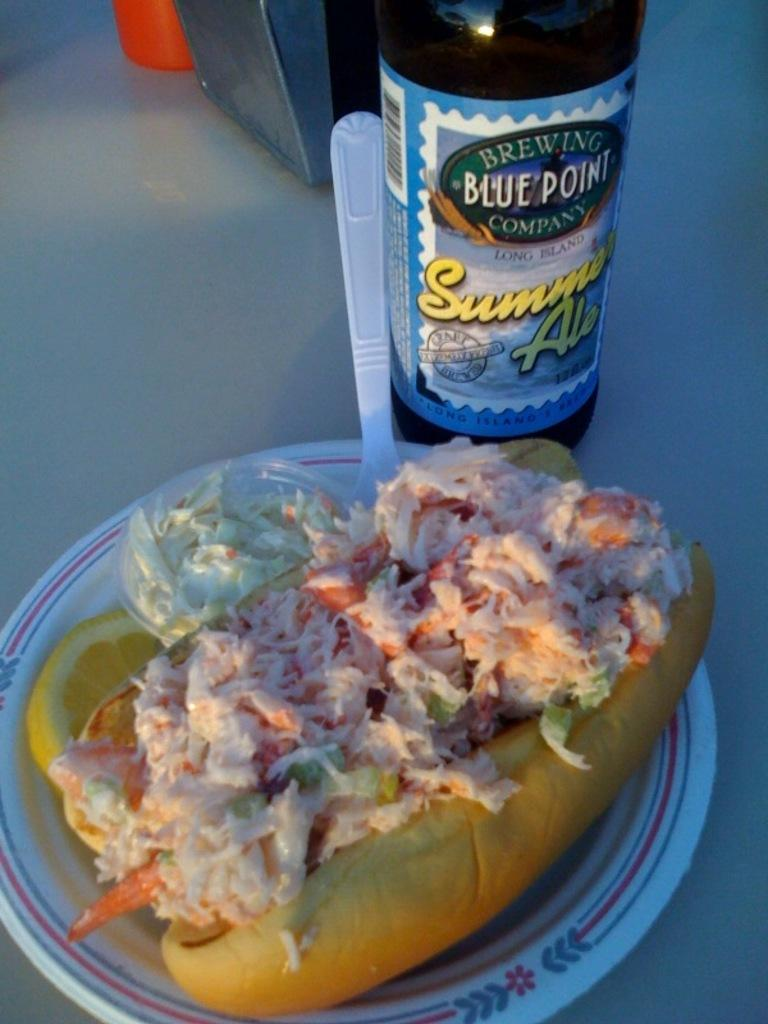Provide a one-sentence caption for the provided image. A hot dog with coleslaw next to a bottle of Sunny Ale. 